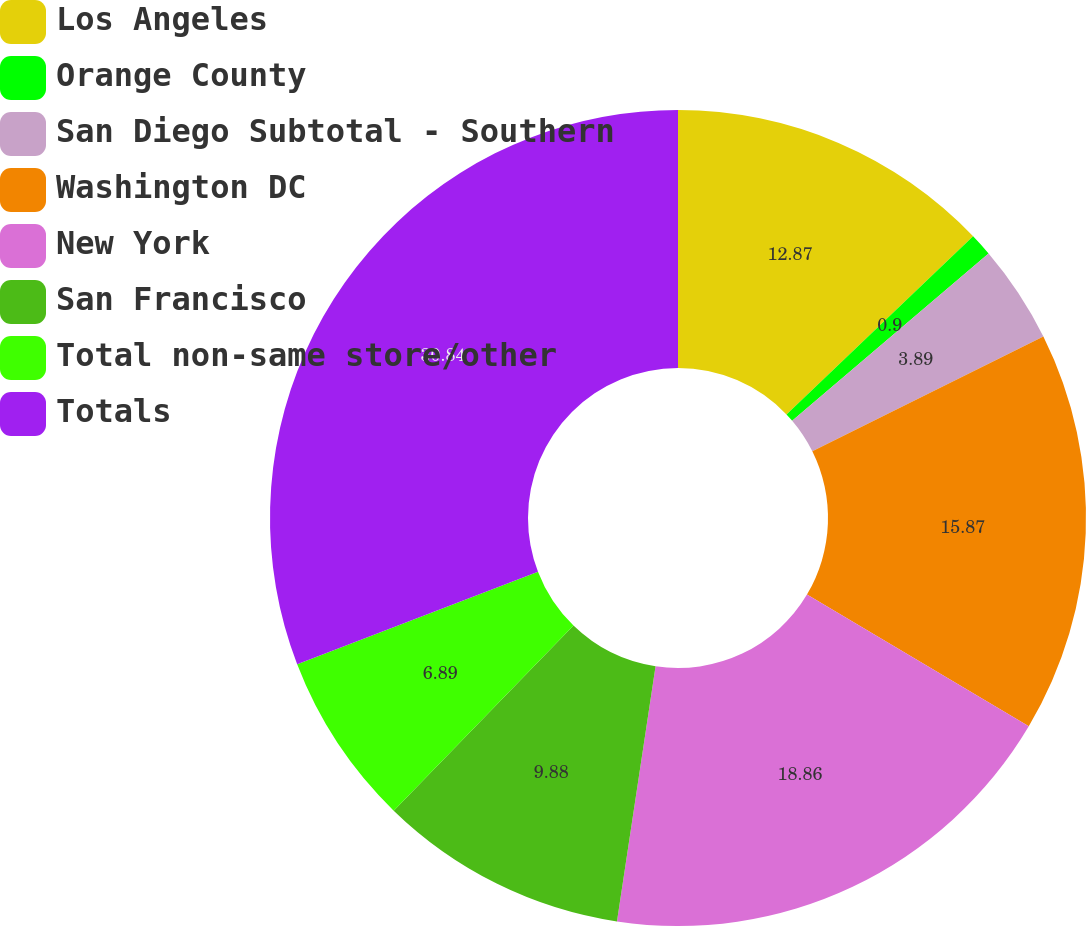<chart> <loc_0><loc_0><loc_500><loc_500><pie_chart><fcel>Los Angeles<fcel>Orange County<fcel>San Diego Subtotal - Southern<fcel>Washington DC<fcel>New York<fcel>San Francisco<fcel>Total non-same store/other<fcel>Totals<nl><fcel>12.87%<fcel>0.9%<fcel>3.89%<fcel>15.87%<fcel>18.86%<fcel>9.88%<fcel>6.89%<fcel>30.84%<nl></chart> 